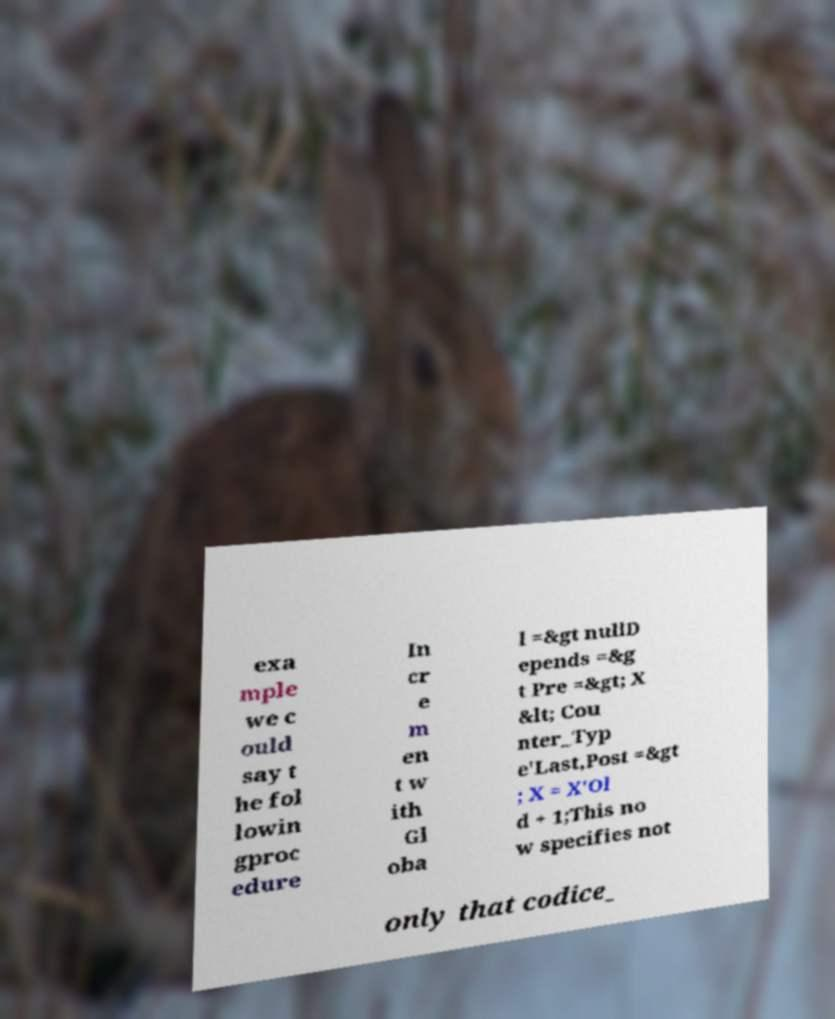Can you read and provide the text displayed in the image?This photo seems to have some interesting text. Can you extract and type it out for me? exa mple we c ould say t he fol lowin gproc edure In cr e m en t w ith Gl oba l =&gt nullD epends =&g t Pre =&gt; X &lt; Cou nter_Typ e'Last,Post =&gt ; X = X'Ol d + 1;This no w specifies not only that codice_ 